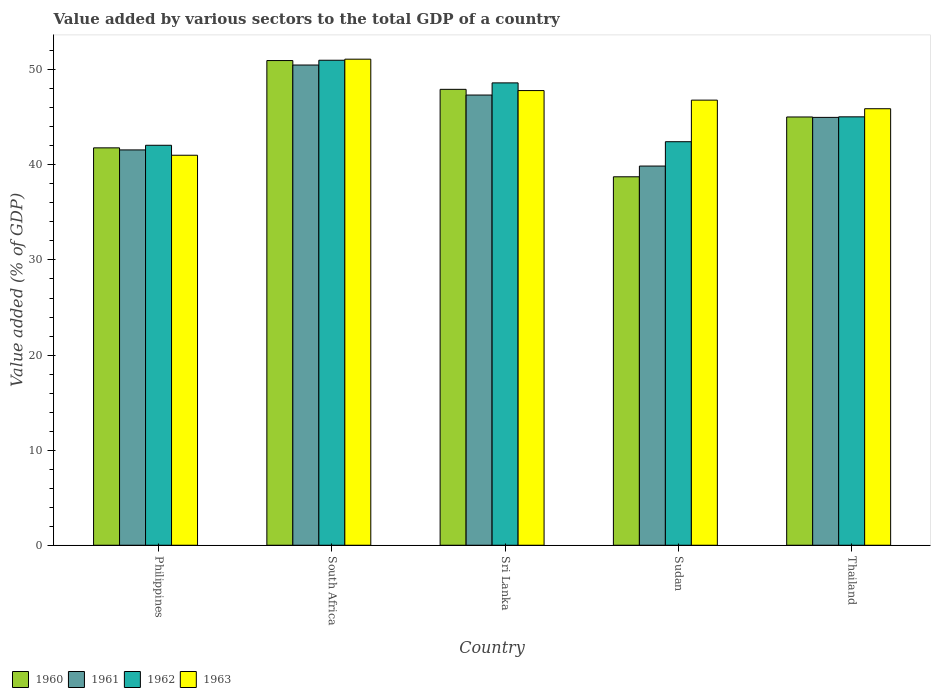How many groups of bars are there?
Offer a very short reply. 5. Are the number of bars on each tick of the X-axis equal?
Provide a short and direct response. Yes. How many bars are there on the 1st tick from the left?
Your answer should be very brief. 4. What is the label of the 5th group of bars from the left?
Keep it short and to the point. Thailand. In how many cases, is the number of bars for a given country not equal to the number of legend labels?
Give a very brief answer. 0. What is the value added by various sectors to the total GDP in 1960 in Philippines?
Ensure brevity in your answer.  41.79. Across all countries, what is the maximum value added by various sectors to the total GDP in 1963?
Offer a very short reply. 51.12. Across all countries, what is the minimum value added by various sectors to the total GDP in 1960?
Offer a very short reply. 38.75. In which country was the value added by various sectors to the total GDP in 1960 maximum?
Make the answer very short. South Africa. In which country was the value added by various sectors to the total GDP in 1962 minimum?
Your answer should be very brief. Philippines. What is the total value added by various sectors to the total GDP in 1962 in the graph?
Your response must be concise. 229.18. What is the difference between the value added by various sectors to the total GDP in 1961 in Philippines and that in South Africa?
Make the answer very short. -8.93. What is the difference between the value added by various sectors to the total GDP in 1960 in South Africa and the value added by various sectors to the total GDP in 1962 in Philippines?
Your answer should be very brief. 8.91. What is the average value added by various sectors to the total GDP in 1961 per country?
Make the answer very short. 44.86. What is the difference between the value added by various sectors to the total GDP of/in 1960 and value added by various sectors to the total GDP of/in 1963 in South Africa?
Your answer should be very brief. -0.15. In how many countries, is the value added by various sectors to the total GDP in 1962 greater than 38 %?
Offer a terse response. 5. What is the ratio of the value added by various sectors to the total GDP in 1962 in Philippines to that in Sudan?
Keep it short and to the point. 0.99. Is the difference between the value added by various sectors to the total GDP in 1960 in South Africa and Thailand greater than the difference between the value added by various sectors to the total GDP in 1963 in South Africa and Thailand?
Make the answer very short. Yes. What is the difference between the highest and the second highest value added by various sectors to the total GDP in 1960?
Your response must be concise. 5.93. What is the difference between the highest and the lowest value added by various sectors to the total GDP in 1963?
Provide a succinct answer. 10.1. What does the 4th bar from the left in South Africa represents?
Offer a terse response. 1963. Is it the case that in every country, the sum of the value added by various sectors to the total GDP in 1961 and value added by various sectors to the total GDP in 1963 is greater than the value added by various sectors to the total GDP in 1960?
Your response must be concise. Yes. How many bars are there?
Provide a short and direct response. 20. How many countries are there in the graph?
Keep it short and to the point. 5. What is the difference between two consecutive major ticks on the Y-axis?
Your response must be concise. 10. Does the graph contain any zero values?
Provide a succinct answer. No. Where does the legend appear in the graph?
Your answer should be very brief. Bottom left. What is the title of the graph?
Keep it short and to the point. Value added by various sectors to the total GDP of a country. Does "1985" appear as one of the legend labels in the graph?
Your response must be concise. No. What is the label or title of the X-axis?
Give a very brief answer. Country. What is the label or title of the Y-axis?
Ensure brevity in your answer.  Value added (% of GDP). What is the Value added (% of GDP) in 1960 in Philippines?
Your answer should be very brief. 41.79. What is the Value added (% of GDP) of 1961 in Philippines?
Offer a very short reply. 41.57. What is the Value added (% of GDP) in 1962 in Philippines?
Make the answer very short. 42.06. What is the Value added (% of GDP) in 1963 in Philippines?
Keep it short and to the point. 41.01. What is the Value added (% of GDP) of 1960 in South Africa?
Give a very brief answer. 50.97. What is the Value added (% of GDP) in 1961 in South Africa?
Make the answer very short. 50.5. What is the Value added (% of GDP) of 1962 in South Africa?
Your answer should be compact. 51.01. What is the Value added (% of GDP) in 1963 in South Africa?
Provide a succinct answer. 51.12. What is the Value added (% of GDP) in 1960 in Sri Lanka?
Your answer should be very brief. 47.95. What is the Value added (% of GDP) in 1961 in Sri Lanka?
Your response must be concise. 47.35. What is the Value added (% of GDP) of 1962 in Sri Lanka?
Ensure brevity in your answer.  48.62. What is the Value added (% of GDP) in 1963 in Sri Lanka?
Provide a short and direct response. 47.82. What is the Value added (% of GDP) of 1960 in Sudan?
Give a very brief answer. 38.75. What is the Value added (% of GDP) of 1961 in Sudan?
Keep it short and to the point. 39.88. What is the Value added (% of GDP) in 1962 in Sudan?
Make the answer very short. 42.44. What is the Value added (% of GDP) in 1963 in Sudan?
Offer a terse response. 46.81. What is the Value added (% of GDP) of 1960 in Thailand?
Provide a succinct answer. 45.04. What is the Value added (% of GDP) of 1961 in Thailand?
Provide a short and direct response. 45. What is the Value added (% of GDP) of 1962 in Thailand?
Keep it short and to the point. 45.05. What is the Value added (% of GDP) of 1963 in Thailand?
Provide a succinct answer. 45.91. Across all countries, what is the maximum Value added (% of GDP) of 1960?
Make the answer very short. 50.97. Across all countries, what is the maximum Value added (% of GDP) in 1961?
Make the answer very short. 50.5. Across all countries, what is the maximum Value added (% of GDP) in 1962?
Offer a terse response. 51.01. Across all countries, what is the maximum Value added (% of GDP) in 1963?
Offer a terse response. 51.12. Across all countries, what is the minimum Value added (% of GDP) in 1960?
Provide a succinct answer. 38.75. Across all countries, what is the minimum Value added (% of GDP) in 1961?
Offer a terse response. 39.88. Across all countries, what is the minimum Value added (% of GDP) in 1962?
Provide a succinct answer. 42.06. Across all countries, what is the minimum Value added (% of GDP) in 1963?
Keep it short and to the point. 41.01. What is the total Value added (% of GDP) of 1960 in the graph?
Your answer should be very brief. 224.5. What is the total Value added (% of GDP) in 1961 in the graph?
Your answer should be compact. 224.3. What is the total Value added (% of GDP) in 1962 in the graph?
Keep it short and to the point. 229.18. What is the total Value added (% of GDP) in 1963 in the graph?
Your answer should be compact. 232.67. What is the difference between the Value added (% of GDP) in 1960 in Philippines and that in South Africa?
Provide a short and direct response. -9.18. What is the difference between the Value added (% of GDP) of 1961 in Philippines and that in South Africa?
Your response must be concise. -8.93. What is the difference between the Value added (% of GDP) in 1962 in Philippines and that in South Africa?
Your response must be concise. -8.94. What is the difference between the Value added (% of GDP) in 1963 in Philippines and that in South Africa?
Offer a very short reply. -10.1. What is the difference between the Value added (% of GDP) of 1960 in Philippines and that in Sri Lanka?
Your response must be concise. -6.15. What is the difference between the Value added (% of GDP) in 1961 in Philippines and that in Sri Lanka?
Provide a short and direct response. -5.77. What is the difference between the Value added (% of GDP) in 1962 in Philippines and that in Sri Lanka?
Ensure brevity in your answer.  -6.56. What is the difference between the Value added (% of GDP) in 1963 in Philippines and that in Sri Lanka?
Offer a very short reply. -6.8. What is the difference between the Value added (% of GDP) of 1960 in Philippines and that in Sudan?
Make the answer very short. 3.04. What is the difference between the Value added (% of GDP) of 1961 in Philippines and that in Sudan?
Your answer should be compact. 1.7. What is the difference between the Value added (% of GDP) in 1962 in Philippines and that in Sudan?
Give a very brief answer. -0.38. What is the difference between the Value added (% of GDP) of 1963 in Philippines and that in Sudan?
Your answer should be compact. -5.8. What is the difference between the Value added (% of GDP) in 1960 in Philippines and that in Thailand?
Offer a terse response. -3.25. What is the difference between the Value added (% of GDP) of 1961 in Philippines and that in Thailand?
Your response must be concise. -3.42. What is the difference between the Value added (% of GDP) of 1962 in Philippines and that in Thailand?
Keep it short and to the point. -2.99. What is the difference between the Value added (% of GDP) of 1963 in Philippines and that in Thailand?
Make the answer very short. -4.89. What is the difference between the Value added (% of GDP) in 1960 in South Africa and that in Sri Lanka?
Keep it short and to the point. 3.03. What is the difference between the Value added (% of GDP) of 1961 in South Africa and that in Sri Lanka?
Give a very brief answer. 3.16. What is the difference between the Value added (% of GDP) in 1962 in South Africa and that in Sri Lanka?
Offer a terse response. 2.38. What is the difference between the Value added (% of GDP) in 1963 in South Africa and that in Sri Lanka?
Keep it short and to the point. 3.3. What is the difference between the Value added (% of GDP) in 1960 in South Africa and that in Sudan?
Your answer should be compact. 12.22. What is the difference between the Value added (% of GDP) in 1961 in South Africa and that in Sudan?
Your answer should be very brief. 10.63. What is the difference between the Value added (% of GDP) in 1962 in South Africa and that in Sudan?
Give a very brief answer. 8.57. What is the difference between the Value added (% of GDP) in 1963 in South Africa and that in Sudan?
Offer a terse response. 4.31. What is the difference between the Value added (% of GDP) in 1960 in South Africa and that in Thailand?
Give a very brief answer. 5.93. What is the difference between the Value added (% of GDP) in 1961 in South Africa and that in Thailand?
Provide a short and direct response. 5.51. What is the difference between the Value added (% of GDP) in 1962 in South Africa and that in Thailand?
Ensure brevity in your answer.  5.95. What is the difference between the Value added (% of GDP) in 1963 in South Africa and that in Thailand?
Make the answer very short. 5.21. What is the difference between the Value added (% of GDP) in 1960 in Sri Lanka and that in Sudan?
Your answer should be very brief. 9.2. What is the difference between the Value added (% of GDP) in 1961 in Sri Lanka and that in Sudan?
Offer a terse response. 7.47. What is the difference between the Value added (% of GDP) of 1962 in Sri Lanka and that in Sudan?
Your answer should be very brief. 6.19. What is the difference between the Value added (% of GDP) in 1963 in Sri Lanka and that in Sudan?
Provide a succinct answer. 1.01. What is the difference between the Value added (% of GDP) in 1960 in Sri Lanka and that in Thailand?
Your answer should be compact. 2.91. What is the difference between the Value added (% of GDP) in 1961 in Sri Lanka and that in Thailand?
Keep it short and to the point. 2.35. What is the difference between the Value added (% of GDP) of 1962 in Sri Lanka and that in Thailand?
Your answer should be very brief. 3.57. What is the difference between the Value added (% of GDP) in 1963 in Sri Lanka and that in Thailand?
Ensure brevity in your answer.  1.91. What is the difference between the Value added (% of GDP) of 1960 in Sudan and that in Thailand?
Offer a very short reply. -6.29. What is the difference between the Value added (% of GDP) in 1961 in Sudan and that in Thailand?
Offer a very short reply. -5.12. What is the difference between the Value added (% of GDP) of 1962 in Sudan and that in Thailand?
Give a very brief answer. -2.62. What is the difference between the Value added (% of GDP) of 1963 in Sudan and that in Thailand?
Provide a short and direct response. 0.9. What is the difference between the Value added (% of GDP) in 1960 in Philippines and the Value added (% of GDP) in 1961 in South Africa?
Your answer should be compact. -8.71. What is the difference between the Value added (% of GDP) of 1960 in Philippines and the Value added (% of GDP) of 1962 in South Africa?
Your response must be concise. -9.21. What is the difference between the Value added (% of GDP) in 1960 in Philippines and the Value added (% of GDP) in 1963 in South Africa?
Your answer should be compact. -9.33. What is the difference between the Value added (% of GDP) in 1961 in Philippines and the Value added (% of GDP) in 1962 in South Africa?
Offer a terse response. -9.43. What is the difference between the Value added (% of GDP) of 1961 in Philippines and the Value added (% of GDP) of 1963 in South Africa?
Provide a short and direct response. -9.54. What is the difference between the Value added (% of GDP) of 1962 in Philippines and the Value added (% of GDP) of 1963 in South Africa?
Offer a very short reply. -9.05. What is the difference between the Value added (% of GDP) of 1960 in Philippines and the Value added (% of GDP) of 1961 in Sri Lanka?
Keep it short and to the point. -5.55. What is the difference between the Value added (% of GDP) of 1960 in Philippines and the Value added (% of GDP) of 1962 in Sri Lanka?
Give a very brief answer. -6.83. What is the difference between the Value added (% of GDP) of 1960 in Philippines and the Value added (% of GDP) of 1963 in Sri Lanka?
Ensure brevity in your answer.  -6.03. What is the difference between the Value added (% of GDP) in 1961 in Philippines and the Value added (% of GDP) in 1962 in Sri Lanka?
Your answer should be compact. -7.05. What is the difference between the Value added (% of GDP) of 1961 in Philippines and the Value added (% of GDP) of 1963 in Sri Lanka?
Your answer should be very brief. -6.24. What is the difference between the Value added (% of GDP) in 1962 in Philippines and the Value added (% of GDP) in 1963 in Sri Lanka?
Your answer should be very brief. -5.75. What is the difference between the Value added (% of GDP) in 1960 in Philippines and the Value added (% of GDP) in 1961 in Sudan?
Ensure brevity in your answer.  1.91. What is the difference between the Value added (% of GDP) in 1960 in Philippines and the Value added (% of GDP) in 1962 in Sudan?
Keep it short and to the point. -0.65. What is the difference between the Value added (% of GDP) in 1960 in Philippines and the Value added (% of GDP) in 1963 in Sudan?
Provide a short and direct response. -5.02. What is the difference between the Value added (% of GDP) of 1961 in Philippines and the Value added (% of GDP) of 1962 in Sudan?
Your response must be concise. -0.86. What is the difference between the Value added (% of GDP) in 1961 in Philippines and the Value added (% of GDP) in 1963 in Sudan?
Provide a succinct answer. -5.24. What is the difference between the Value added (% of GDP) of 1962 in Philippines and the Value added (% of GDP) of 1963 in Sudan?
Offer a very short reply. -4.75. What is the difference between the Value added (% of GDP) in 1960 in Philippines and the Value added (% of GDP) in 1961 in Thailand?
Make the answer very short. -3.21. What is the difference between the Value added (% of GDP) of 1960 in Philippines and the Value added (% of GDP) of 1962 in Thailand?
Keep it short and to the point. -3.26. What is the difference between the Value added (% of GDP) in 1960 in Philippines and the Value added (% of GDP) in 1963 in Thailand?
Keep it short and to the point. -4.12. What is the difference between the Value added (% of GDP) in 1961 in Philippines and the Value added (% of GDP) in 1962 in Thailand?
Keep it short and to the point. -3.48. What is the difference between the Value added (% of GDP) of 1961 in Philippines and the Value added (% of GDP) of 1963 in Thailand?
Offer a very short reply. -4.33. What is the difference between the Value added (% of GDP) in 1962 in Philippines and the Value added (% of GDP) in 1963 in Thailand?
Make the answer very short. -3.84. What is the difference between the Value added (% of GDP) of 1960 in South Africa and the Value added (% of GDP) of 1961 in Sri Lanka?
Your answer should be compact. 3.63. What is the difference between the Value added (% of GDP) in 1960 in South Africa and the Value added (% of GDP) in 1962 in Sri Lanka?
Your answer should be compact. 2.35. What is the difference between the Value added (% of GDP) of 1960 in South Africa and the Value added (% of GDP) of 1963 in Sri Lanka?
Make the answer very short. 3.16. What is the difference between the Value added (% of GDP) of 1961 in South Africa and the Value added (% of GDP) of 1962 in Sri Lanka?
Keep it short and to the point. 1.88. What is the difference between the Value added (% of GDP) in 1961 in South Africa and the Value added (% of GDP) in 1963 in Sri Lanka?
Offer a terse response. 2.69. What is the difference between the Value added (% of GDP) in 1962 in South Africa and the Value added (% of GDP) in 1963 in Sri Lanka?
Provide a succinct answer. 3.19. What is the difference between the Value added (% of GDP) of 1960 in South Africa and the Value added (% of GDP) of 1961 in Sudan?
Your answer should be very brief. 11.09. What is the difference between the Value added (% of GDP) in 1960 in South Africa and the Value added (% of GDP) in 1962 in Sudan?
Give a very brief answer. 8.53. What is the difference between the Value added (% of GDP) of 1960 in South Africa and the Value added (% of GDP) of 1963 in Sudan?
Offer a very short reply. 4.16. What is the difference between the Value added (% of GDP) in 1961 in South Africa and the Value added (% of GDP) in 1962 in Sudan?
Give a very brief answer. 8.07. What is the difference between the Value added (% of GDP) of 1961 in South Africa and the Value added (% of GDP) of 1963 in Sudan?
Ensure brevity in your answer.  3.69. What is the difference between the Value added (% of GDP) of 1962 in South Africa and the Value added (% of GDP) of 1963 in Sudan?
Offer a terse response. 4.19. What is the difference between the Value added (% of GDP) in 1960 in South Africa and the Value added (% of GDP) in 1961 in Thailand?
Your answer should be very brief. 5.98. What is the difference between the Value added (% of GDP) of 1960 in South Africa and the Value added (% of GDP) of 1962 in Thailand?
Ensure brevity in your answer.  5.92. What is the difference between the Value added (% of GDP) of 1960 in South Africa and the Value added (% of GDP) of 1963 in Thailand?
Make the answer very short. 5.06. What is the difference between the Value added (% of GDP) of 1961 in South Africa and the Value added (% of GDP) of 1962 in Thailand?
Your response must be concise. 5.45. What is the difference between the Value added (% of GDP) in 1961 in South Africa and the Value added (% of GDP) in 1963 in Thailand?
Make the answer very short. 4.6. What is the difference between the Value added (% of GDP) in 1962 in South Africa and the Value added (% of GDP) in 1963 in Thailand?
Offer a very short reply. 5.1. What is the difference between the Value added (% of GDP) in 1960 in Sri Lanka and the Value added (% of GDP) in 1961 in Sudan?
Make the answer very short. 8.07. What is the difference between the Value added (% of GDP) of 1960 in Sri Lanka and the Value added (% of GDP) of 1962 in Sudan?
Provide a succinct answer. 5.51. What is the difference between the Value added (% of GDP) of 1960 in Sri Lanka and the Value added (% of GDP) of 1963 in Sudan?
Provide a succinct answer. 1.14. What is the difference between the Value added (% of GDP) in 1961 in Sri Lanka and the Value added (% of GDP) in 1962 in Sudan?
Offer a very short reply. 4.91. What is the difference between the Value added (% of GDP) in 1961 in Sri Lanka and the Value added (% of GDP) in 1963 in Sudan?
Provide a succinct answer. 0.53. What is the difference between the Value added (% of GDP) in 1962 in Sri Lanka and the Value added (% of GDP) in 1963 in Sudan?
Your answer should be compact. 1.81. What is the difference between the Value added (% of GDP) of 1960 in Sri Lanka and the Value added (% of GDP) of 1961 in Thailand?
Your answer should be compact. 2.95. What is the difference between the Value added (% of GDP) in 1960 in Sri Lanka and the Value added (% of GDP) in 1962 in Thailand?
Ensure brevity in your answer.  2.89. What is the difference between the Value added (% of GDP) in 1960 in Sri Lanka and the Value added (% of GDP) in 1963 in Thailand?
Keep it short and to the point. 2.04. What is the difference between the Value added (% of GDP) of 1961 in Sri Lanka and the Value added (% of GDP) of 1962 in Thailand?
Provide a succinct answer. 2.29. What is the difference between the Value added (% of GDP) of 1961 in Sri Lanka and the Value added (% of GDP) of 1963 in Thailand?
Ensure brevity in your answer.  1.44. What is the difference between the Value added (% of GDP) in 1962 in Sri Lanka and the Value added (% of GDP) in 1963 in Thailand?
Give a very brief answer. 2.72. What is the difference between the Value added (% of GDP) of 1960 in Sudan and the Value added (% of GDP) of 1961 in Thailand?
Your answer should be compact. -6.25. What is the difference between the Value added (% of GDP) in 1960 in Sudan and the Value added (% of GDP) in 1962 in Thailand?
Offer a terse response. -6.31. What is the difference between the Value added (% of GDP) in 1960 in Sudan and the Value added (% of GDP) in 1963 in Thailand?
Make the answer very short. -7.16. What is the difference between the Value added (% of GDP) in 1961 in Sudan and the Value added (% of GDP) in 1962 in Thailand?
Ensure brevity in your answer.  -5.18. What is the difference between the Value added (% of GDP) in 1961 in Sudan and the Value added (% of GDP) in 1963 in Thailand?
Provide a succinct answer. -6.03. What is the difference between the Value added (% of GDP) in 1962 in Sudan and the Value added (% of GDP) in 1963 in Thailand?
Make the answer very short. -3.47. What is the average Value added (% of GDP) in 1960 per country?
Provide a succinct answer. 44.9. What is the average Value added (% of GDP) of 1961 per country?
Give a very brief answer. 44.86. What is the average Value added (% of GDP) of 1962 per country?
Keep it short and to the point. 45.84. What is the average Value added (% of GDP) of 1963 per country?
Provide a short and direct response. 46.53. What is the difference between the Value added (% of GDP) of 1960 and Value added (% of GDP) of 1961 in Philippines?
Give a very brief answer. 0.22. What is the difference between the Value added (% of GDP) of 1960 and Value added (% of GDP) of 1962 in Philippines?
Provide a succinct answer. -0.27. What is the difference between the Value added (% of GDP) of 1960 and Value added (% of GDP) of 1963 in Philippines?
Offer a very short reply. 0.78. What is the difference between the Value added (% of GDP) of 1961 and Value added (% of GDP) of 1962 in Philippines?
Your response must be concise. -0.49. What is the difference between the Value added (% of GDP) in 1961 and Value added (% of GDP) in 1963 in Philippines?
Provide a succinct answer. 0.56. What is the difference between the Value added (% of GDP) of 1962 and Value added (% of GDP) of 1963 in Philippines?
Your answer should be compact. 1.05. What is the difference between the Value added (% of GDP) in 1960 and Value added (% of GDP) in 1961 in South Africa?
Provide a short and direct response. 0.47. What is the difference between the Value added (% of GDP) in 1960 and Value added (% of GDP) in 1962 in South Africa?
Offer a very short reply. -0.03. What is the difference between the Value added (% of GDP) in 1960 and Value added (% of GDP) in 1963 in South Africa?
Provide a succinct answer. -0.15. What is the difference between the Value added (% of GDP) in 1961 and Value added (% of GDP) in 1962 in South Africa?
Give a very brief answer. -0.5. What is the difference between the Value added (% of GDP) of 1961 and Value added (% of GDP) of 1963 in South Africa?
Offer a very short reply. -0.61. What is the difference between the Value added (% of GDP) in 1962 and Value added (% of GDP) in 1963 in South Africa?
Your answer should be compact. -0.11. What is the difference between the Value added (% of GDP) of 1960 and Value added (% of GDP) of 1961 in Sri Lanka?
Offer a terse response. 0.6. What is the difference between the Value added (% of GDP) in 1960 and Value added (% of GDP) in 1962 in Sri Lanka?
Make the answer very short. -0.68. What is the difference between the Value added (% of GDP) in 1960 and Value added (% of GDP) in 1963 in Sri Lanka?
Offer a terse response. 0.13. What is the difference between the Value added (% of GDP) of 1961 and Value added (% of GDP) of 1962 in Sri Lanka?
Give a very brief answer. -1.28. What is the difference between the Value added (% of GDP) of 1961 and Value added (% of GDP) of 1963 in Sri Lanka?
Provide a succinct answer. -0.47. What is the difference between the Value added (% of GDP) of 1962 and Value added (% of GDP) of 1963 in Sri Lanka?
Your response must be concise. 0.81. What is the difference between the Value added (% of GDP) of 1960 and Value added (% of GDP) of 1961 in Sudan?
Offer a very short reply. -1.13. What is the difference between the Value added (% of GDP) of 1960 and Value added (% of GDP) of 1962 in Sudan?
Offer a terse response. -3.69. What is the difference between the Value added (% of GDP) in 1960 and Value added (% of GDP) in 1963 in Sudan?
Provide a succinct answer. -8.06. What is the difference between the Value added (% of GDP) of 1961 and Value added (% of GDP) of 1962 in Sudan?
Your response must be concise. -2.56. What is the difference between the Value added (% of GDP) of 1961 and Value added (% of GDP) of 1963 in Sudan?
Make the answer very short. -6.93. What is the difference between the Value added (% of GDP) of 1962 and Value added (% of GDP) of 1963 in Sudan?
Offer a terse response. -4.37. What is the difference between the Value added (% of GDP) in 1960 and Value added (% of GDP) in 1961 in Thailand?
Keep it short and to the point. 0.04. What is the difference between the Value added (% of GDP) in 1960 and Value added (% of GDP) in 1962 in Thailand?
Your response must be concise. -0.02. What is the difference between the Value added (% of GDP) in 1960 and Value added (% of GDP) in 1963 in Thailand?
Offer a very short reply. -0.87. What is the difference between the Value added (% of GDP) in 1961 and Value added (% of GDP) in 1962 in Thailand?
Your answer should be very brief. -0.06. What is the difference between the Value added (% of GDP) in 1961 and Value added (% of GDP) in 1963 in Thailand?
Offer a terse response. -0.91. What is the difference between the Value added (% of GDP) in 1962 and Value added (% of GDP) in 1963 in Thailand?
Ensure brevity in your answer.  -0.85. What is the ratio of the Value added (% of GDP) of 1960 in Philippines to that in South Africa?
Ensure brevity in your answer.  0.82. What is the ratio of the Value added (% of GDP) of 1961 in Philippines to that in South Africa?
Make the answer very short. 0.82. What is the ratio of the Value added (% of GDP) in 1962 in Philippines to that in South Africa?
Offer a terse response. 0.82. What is the ratio of the Value added (% of GDP) of 1963 in Philippines to that in South Africa?
Provide a short and direct response. 0.8. What is the ratio of the Value added (% of GDP) in 1960 in Philippines to that in Sri Lanka?
Your answer should be very brief. 0.87. What is the ratio of the Value added (% of GDP) in 1961 in Philippines to that in Sri Lanka?
Offer a very short reply. 0.88. What is the ratio of the Value added (% of GDP) of 1962 in Philippines to that in Sri Lanka?
Offer a very short reply. 0.87. What is the ratio of the Value added (% of GDP) of 1963 in Philippines to that in Sri Lanka?
Ensure brevity in your answer.  0.86. What is the ratio of the Value added (% of GDP) in 1960 in Philippines to that in Sudan?
Your answer should be very brief. 1.08. What is the ratio of the Value added (% of GDP) of 1961 in Philippines to that in Sudan?
Your response must be concise. 1.04. What is the ratio of the Value added (% of GDP) of 1963 in Philippines to that in Sudan?
Your response must be concise. 0.88. What is the ratio of the Value added (% of GDP) of 1960 in Philippines to that in Thailand?
Offer a very short reply. 0.93. What is the ratio of the Value added (% of GDP) of 1961 in Philippines to that in Thailand?
Offer a very short reply. 0.92. What is the ratio of the Value added (% of GDP) of 1962 in Philippines to that in Thailand?
Keep it short and to the point. 0.93. What is the ratio of the Value added (% of GDP) in 1963 in Philippines to that in Thailand?
Your answer should be compact. 0.89. What is the ratio of the Value added (% of GDP) in 1960 in South Africa to that in Sri Lanka?
Provide a succinct answer. 1.06. What is the ratio of the Value added (% of GDP) in 1961 in South Africa to that in Sri Lanka?
Your answer should be very brief. 1.07. What is the ratio of the Value added (% of GDP) of 1962 in South Africa to that in Sri Lanka?
Make the answer very short. 1.05. What is the ratio of the Value added (% of GDP) in 1963 in South Africa to that in Sri Lanka?
Make the answer very short. 1.07. What is the ratio of the Value added (% of GDP) of 1960 in South Africa to that in Sudan?
Give a very brief answer. 1.32. What is the ratio of the Value added (% of GDP) in 1961 in South Africa to that in Sudan?
Give a very brief answer. 1.27. What is the ratio of the Value added (% of GDP) in 1962 in South Africa to that in Sudan?
Your response must be concise. 1.2. What is the ratio of the Value added (% of GDP) in 1963 in South Africa to that in Sudan?
Make the answer very short. 1.09. What is the ratio of the Value added (% of GDP) of 1960 in South Africa to that in Thailand?
Keep it short and to the point. 1.13. What is the ratio of the Value added (% of GDP) of 1961 in South Africa to that in Thailand?
Keep it short and to the point. 1.12. What is the ratio of the Value added (% of GDP) in 1962 in South Africa to that in Thailand?
Provide a succinct answer. 1.13. What is the ratio of the Value added (% of GDP) of 1963 in South Africa to that in Thailand?
Give a very brief answer. 1.11. What is the ratio of the Value added (% of GDP) of 1960 in Sri Lanka to that in Sudan?
Offer a terse response. 1.24. What is the ratio of the Value added (% of GDP) of 1961 in Sri Lanka to that in Sudan?
Your response must be concise. 1.19. What is the ratio of the Value added (% of GDP) of 1962 in Sri Lanka to that in Sudan?
Your answer should be compact. 1.15. What is the ratio of the Value added (% of GDP) in 1963 in Sri Lanka to that in Sudan?
Make the answer very short. 1.02. What is the ratio of the Value added (% of GDP) of 1960 in Sri Lanka to that in Thailand?
Your answer should be compact. 1.06. What is the ratio of the Value added (% of GDP) in 1961 in Sri Lanka to that in Thailand?
Offer a very short reply. 1.05. What is the ratio of the Value added (% of GDP) in 1962 in Sri Lanka to that in Thailand?
Provide a succinct answer. 1.08. What is the ratio of the Value added (% of GDP) in 1963 in Sri Lanka to that in Thailand?
Provide a succinct answer. 1.04. What is the ratio of the Value added (% of GDP) of 1960 in Sudan to that in Thailand?
Offer a very short reply. 0.86. What is the ratio of the Value added (% of GDP) of 1961 in Sudan to that in Thailand?
Offer a very short reply. 0.89. What is the ratio of the Value added (% of GDP) of 1962 in Sudan to that in Thailand?
Give a very brief answer. 0.94. What is the ratio of the Value added (% of GDP) of 1963 in Sudan to that in Thailand?
Ensure brevity in your answer.  1.02. What is the difference between the highest and the second highest Value added (% of GDP) of 1960?
Keep it short and to the point. 3.03. What is the difference between the highest and the second highest Value added (% of GDP) of 1961?
Give a very brief answer. 3.16. What is the difference between the highest and the second highest Value added (% of GDP) in 1962?
Provide a succinct answer. 2.38. What is the difference between the highest and the second highest Value added (% of GDP) in 1963?
Your answer should be very brief. 3.3. What is the difference between the highest and the lowest Value added (% of GDP) in 1960?
Keep it short and to the point. 12.22. What is the difference between the highest and the lowest Value added (% of GDP) of 1961?
Provide a succinct answer. 10.63. What is the difference between the highest and the lowest Value added (% of GDP) of 1962?
Ensure brevity in your answer.  8.94. What is the difference between the highest and the lowest Value added (% of GDP) in 1963?
Keep it short and to the point. 10.1. 